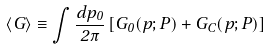<formula> <loc_0><loc_0><loc_500><loc_500>\langle G \rangle \equiv \int \frac { d p _ { 0 } } { 2 \pi } \left [ G _ { 0 } ( p ; P ) + G _ { C } ( p ; P ) \right ]</formula> 